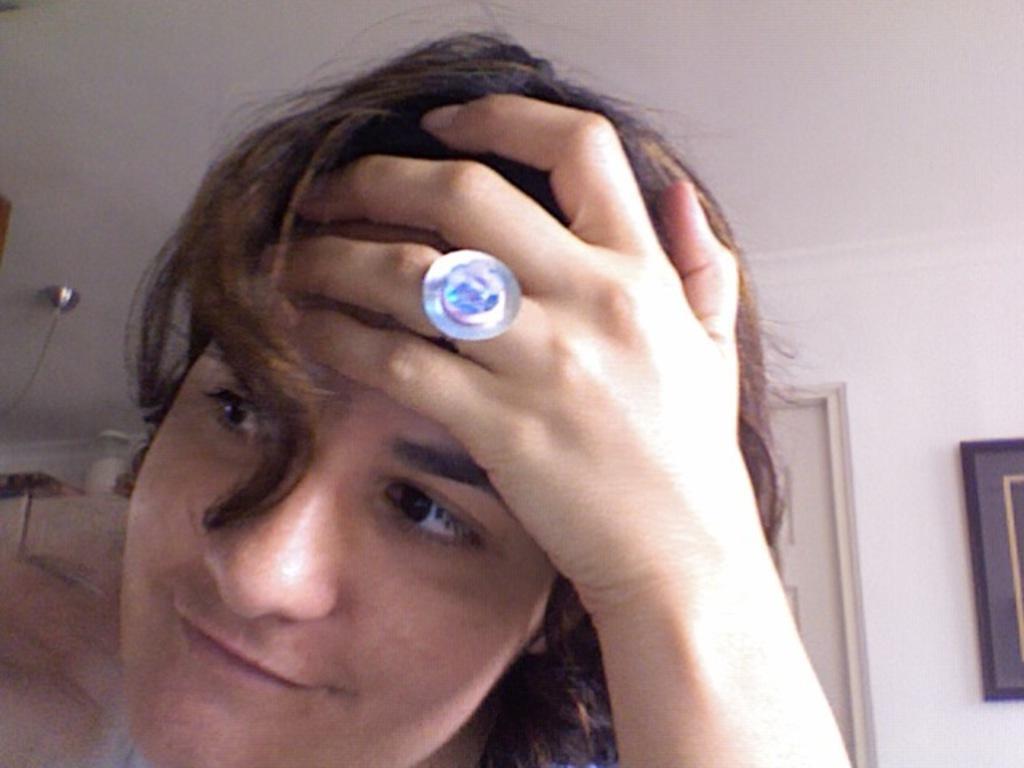Please provide a concise description of this image. In the picture I can see a man is putting the hand on his head and smiling. The man is wearing an object on his finger. In the background I can see a white color ceiling and some object attached to the white color wall. 